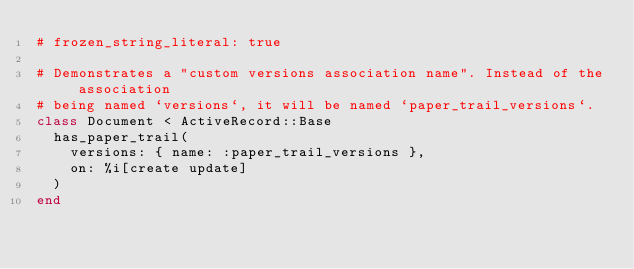Convert code to text. <code><loc_0><loc_0><loc_500><loc_500><_Ruby_># frozen_string_literal: true

# Demonstrates a "custom versions association name". Instead of the association
# being named `versions`, it will be named `paper_trail_versions`.
class Document < ActiveRecord::Base
  has_paper_trail(
    versions: { name: :paper_trail_versions },
    on: %i[create update]
  )
end
</code> 